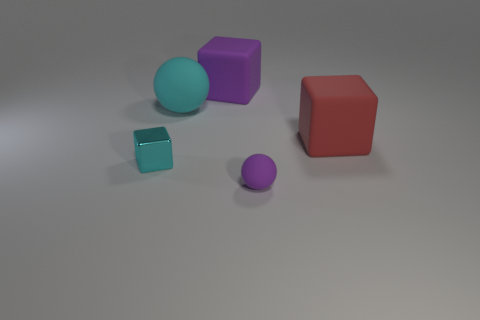What is the shape of the small object that is the same color as the large ball?
Give a very brief answer. Cube. Are there any other things that have the same color as the tiny shiny thing?
Your response must be concise. Yes. There is a cyan object that is made of the same material as the large red thing; what shape is it?
Offer a very short reply. Sphere. The rubber ball that is left of the purple matte thing behind the purple matte object in front of the cyan sphere is what color?
Offer a very short reply. Cyan. There is a big matte sphere; is it the same color as the tiny thing behind the small purple rubber sphere?
Keep it short and to the point. Yes. There is a red matte cube that is behind the purple matte object that is in front of the big purple rubber block; are there any tiny cubes behind it?
Provide a succinct answer. No. What number of other objects are there of the same shape as the cyan matte object?
Provide a succinct answer. 1. How many objects are either things that are behind the tiny purple matte object or cyan objects that are behind the red block?
Make the answer very short. 4. There is a thing that is in front of the red object and left of the large purple block; how big is it?
Your response must be concise. Small. There is a purple thing that is behind the metallic cube; is its shape the same as the big cyan matte thing?
Your answer should be compact. No. 